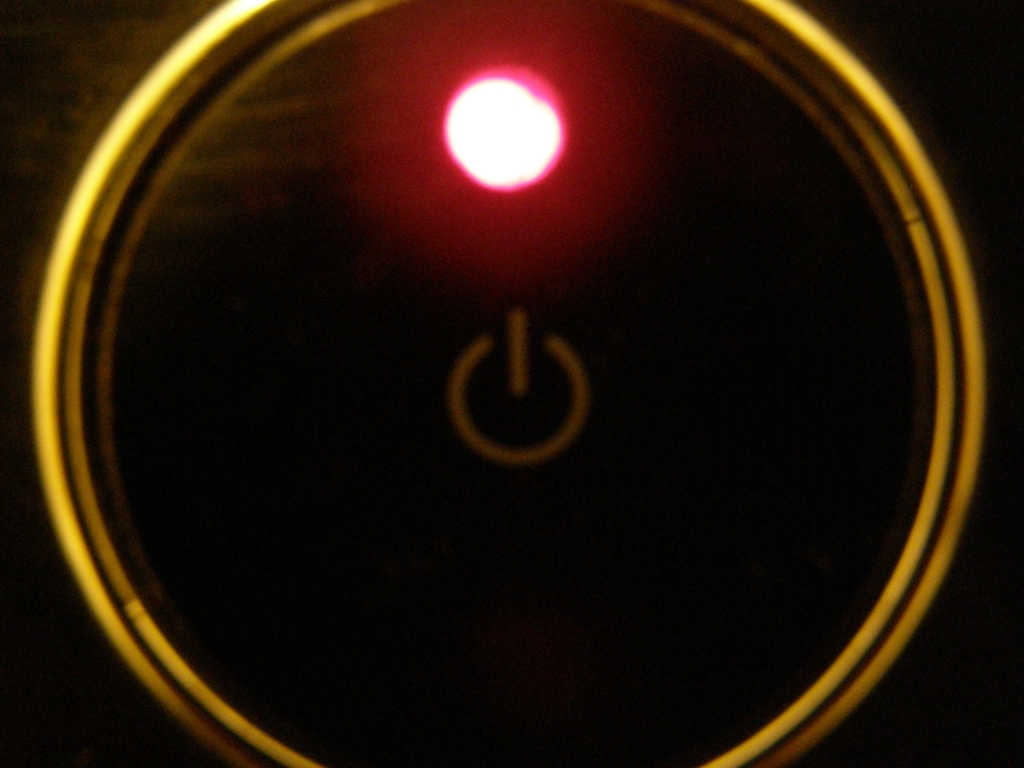Is the background sharp and detailed? The image exhibits a blurred background with low levels of detail, lacking sharpness and clarity. This contributes to a focus on the glowing power button at the center, which becomes the dominant visual element due to the contrast in sharpness and the luminosity of the indicator light. 